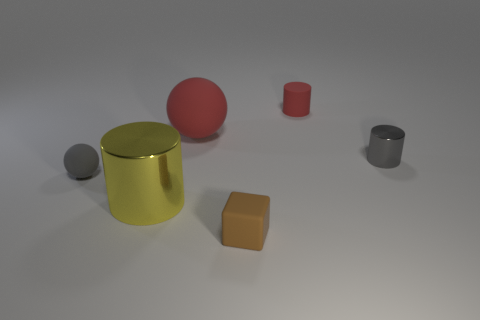There is a thing that is the same size as the yellow shiny cylinder; what is its shape?
Offer a very short reply. Sphere. There is a gray thing that is made of the same material as the tiny red cylinder; what is its size?
Your answer should be very brief. Small. Do the big rubber thing and the brown object have the same shape?
Provide a short and direct response. No. There is a matte ball that is the same size as the brown matte object; what is its color?
Make the answer very short. Gray. The red thing that is the same shape as the tiny gray metal thing is what size?
Provide a succinct answer. Small. What is the shape of the tiny thing that is left of the small brown rubber cube?
Make the answer very short. Sphere. There is a tiny red object; is it the same shape as the big metal object that is left of the tiny gray shiny thing?
Give a very brief answer. Yes. Is the number of small spheres in front of the brown matte thing the same as the number of small red cylinders behind the tiny red rubber object?
Make the answer very short. Yes. There is a rubber thing that is the same color as the small metallic cylinder; what is its shape?
Your answer should be very brief. Sphere. There is a big object behind the large yellow shiny object; is its color the same as the matte object behind the big red sphere?
Ensure brevity in your answer.  Yes. 